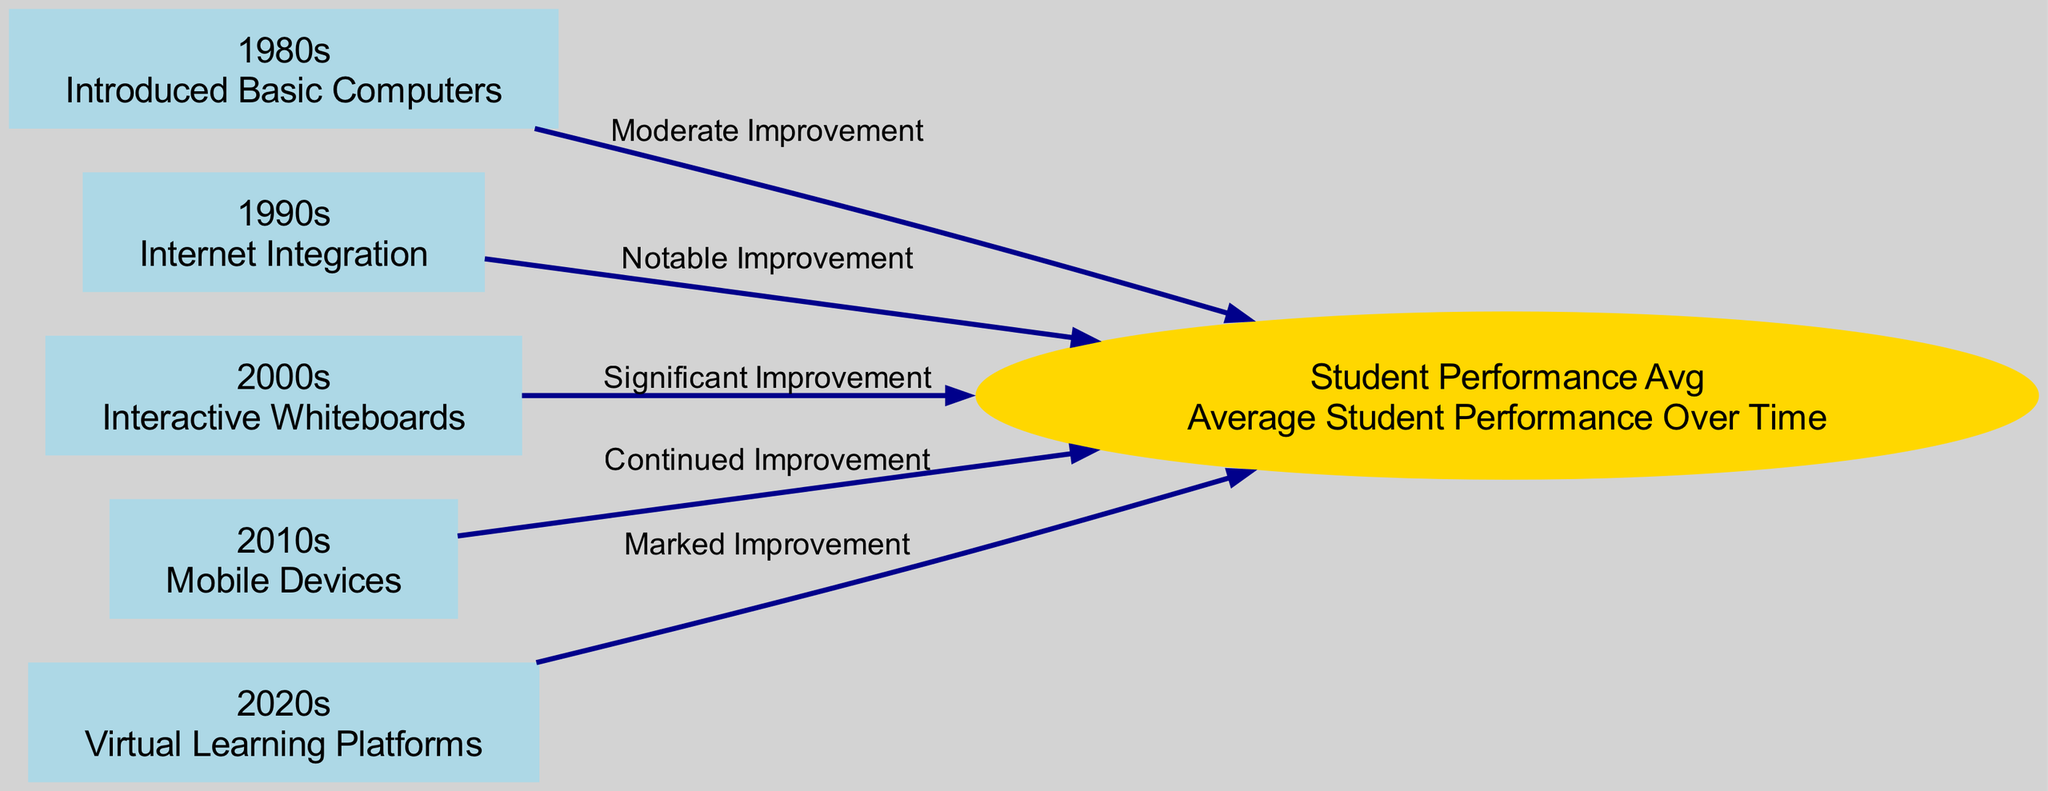What technology was introduced in the 1980s? The diagram shows that the node labeled "1980s" describes the introduction of "Basic Computers". This information can be found directly beneath the label in the node description.
Answer: Basic Computers What is the correlation label between the 1990s and student performance? In the diagram, the edge connecting the node labeled "1990s" to "Student Performance Avg" is labeled "Notable Improvement". This indicates the level of improvement in student performance related to this time period.
Answer: Notable Improvement How many technologies are listed in the diagram? By counting the nodes besides the "Student Performance Avg" node, we find that there are five nodes listed, each representing a decade and an associated technology.
Answer: 5 What level of improvement is associated with mobile devices in the classroom? The diagram connects the "Mobile Devices" node (from the 2010s) to the "Student Performance Avg" node with the label "Continued Improvement", indicating this level of student performance improvement.
Answer: Continued Improvement Which decade shows the most significant improvement in student performance? The connections in the diagram indicate that the "Interactive Whiteboards" in the 2000s have the edge labeled "Significant Improvement", which is higher than others except for the "Virtual Learning Platforms" in the 2020s, which states "Marked Improvement". Thus, by comparing, the 2020s exhibit the most significant improvement.
Answer: Marked Improvement Which decade had moderate improvement in student performance? The edge connecting the "1980s" node with the "Student Performance Avg" node is specifically labeled "Moderate Improvement". This indicates the level of improvement noted for this decade clearly defined in the diagram.
Answer: Moderate Improvement What type of diagram is represented here? This diagram is classified as a Social Science Diagram because it illustrates the relationship between technology usage trends over time and their correlation with student performance improvements, combining social science education and technology data.
Answer: Social Science Diagram What improvement type connects the early internet to student performance? The connection from the "1990s" (Internet Integration) to the "Student Performance Avg" node is characterized by the label "Notable Improvement", thereby indicating the specific type of improvement for that decade.
Answer: Notable Improvement 